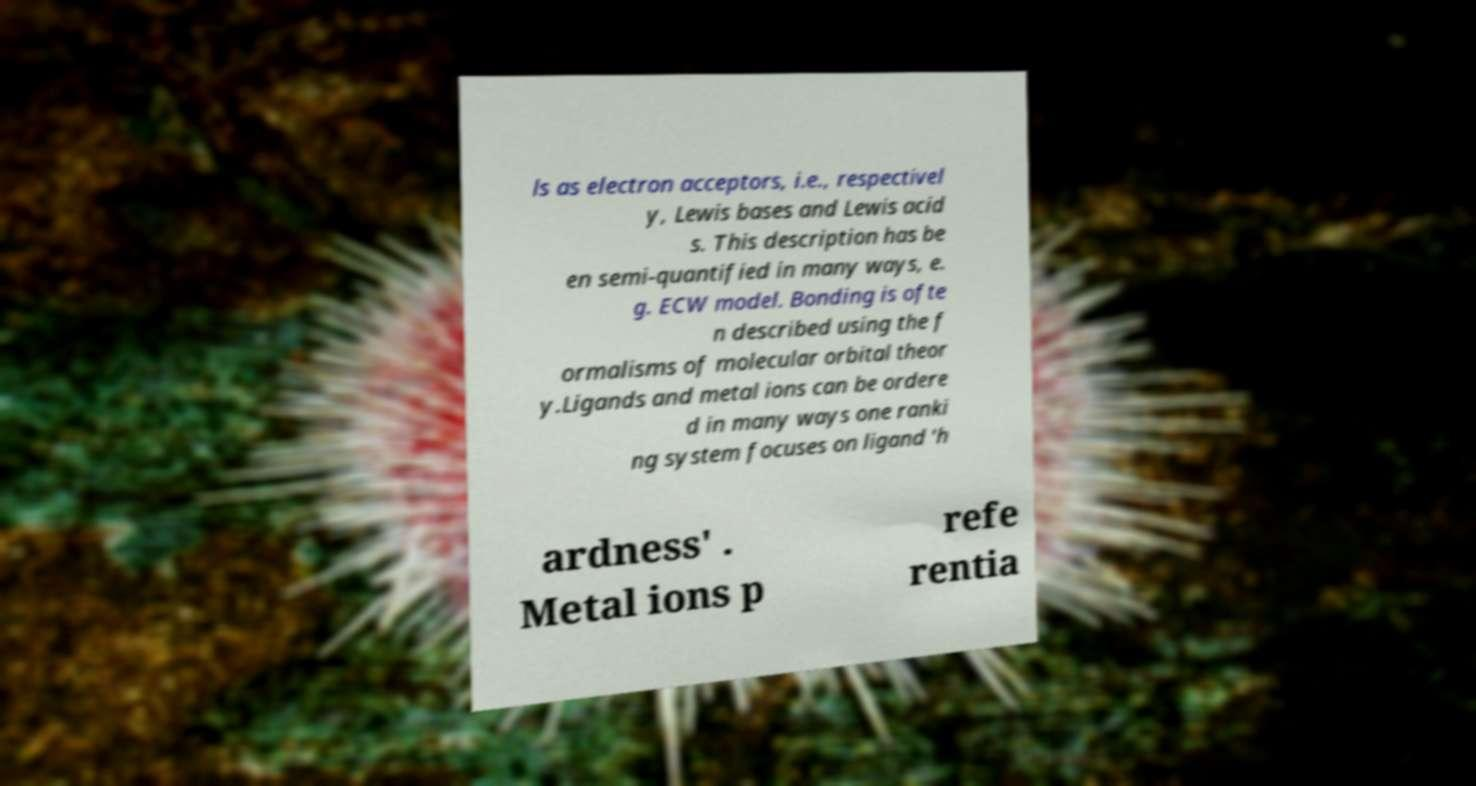I need the written content from this picture converted into text. Can you do that? ls as electron acceptors, i.e., respectivel y, Lewis bases and Lewis acid s. This description has be en semi-quantified in many ways, e. g. ECW model. Bonding is ofte n described using the f ormalisms of molecular orbital theor y.Ligands and metal ions can be ordere d in many ways one ranki ng system focuses on ligand 'h ardness' . Metal ions p refe rentia 